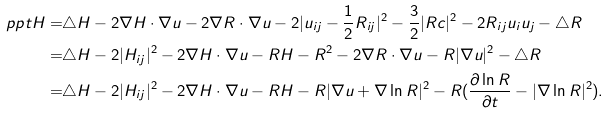Convert formula to latex. <formula><loc_0><loc_0><loc_500><loc_500>\ p p t H = & \triangle H - 2 \nabla H \cdot \nabla u - 2 \nabla R \cdot \nabla u - 2 | u _ { i j } - \frac { 1 } { 2 } R _ { i j } | ^ { 2 } - \frac { 3 } { 2 } | R c | ^ { 2 } - 2 R _ { i j } u _ { i } u _ { j } - \triangle R \\ = & \triangle H - 2 | H _ { i j } | ^ { 2 } - 2 \nabla H \cdot \nabla u - R H - R ^ { 2 } - 2 \nabla R \cdot \nabla u - R | \nabla u | ^ { 2 } - \triangle R \\ = & \triangle H - 2 | H _ { i j } | ^ { 2 } - 2 \nabla H \cdot \nabla u - R H - R | \nabla u + \nabla \ln R | ^ { 2 } - R ( \frac { \partial \ln R } { \partial t } - | \nabla \ln R | ^ { 2 } ) .</formula> 